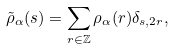<formula> <loc_0><loc_0><loc_500><loc_500>\tilde { \rho } _ { \alpha } ( s ) = \sum _ { r \in \mathbb { Z } } \rho _ { \alpha } ( r ) \delta _ { s , 2 r } ,</formula> 